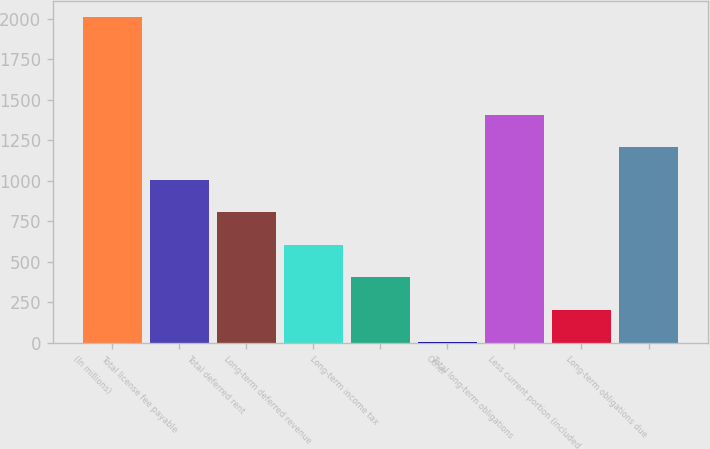Convert chart to OTSL. <chart><loc_0><loc_0><loc_500><loc_500><bar_chart><fcel>(In millions)<fcel>Total license fee payable<fcel>Total deferred rent<fcel>Long-term deferred revenue<fcel>Long-term income tax<fcel>Other<fcel>Total long-term obligations<fcel>Less current portion (included<fcel>Long-term obligations due<nl><fcel>2010<fcel>1006.5<fcel>805.8<fcel>605.1<fcel>404.4<fcel>3<fcel>1407.9<fcel>203.7<fcel>1207.2<nl></chart> 